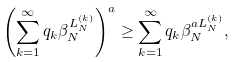<formula> <loc_0><loc_0><loc_500><loc_500>\left ( \sum _ { k = 1 } ^ { \infty } q _ { k } \beta _ { N } ^ { L _ { N } ^ { ( k ) } } \right ) ^ { a } \geq \sum _ { k = 1 } ^ { \infty } q _ { k } \beta _ { N } ^ { a L _ { N } ^ { ( k ) } } ,</formula> 